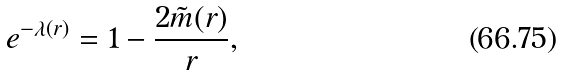<formula> <loc_0><loc_0><loc_500><loc_500>e ^ { - \lambda ( r ) } = 1 - \frac { 2 \tilde { m } ( r ) } { r } ,</formula> 